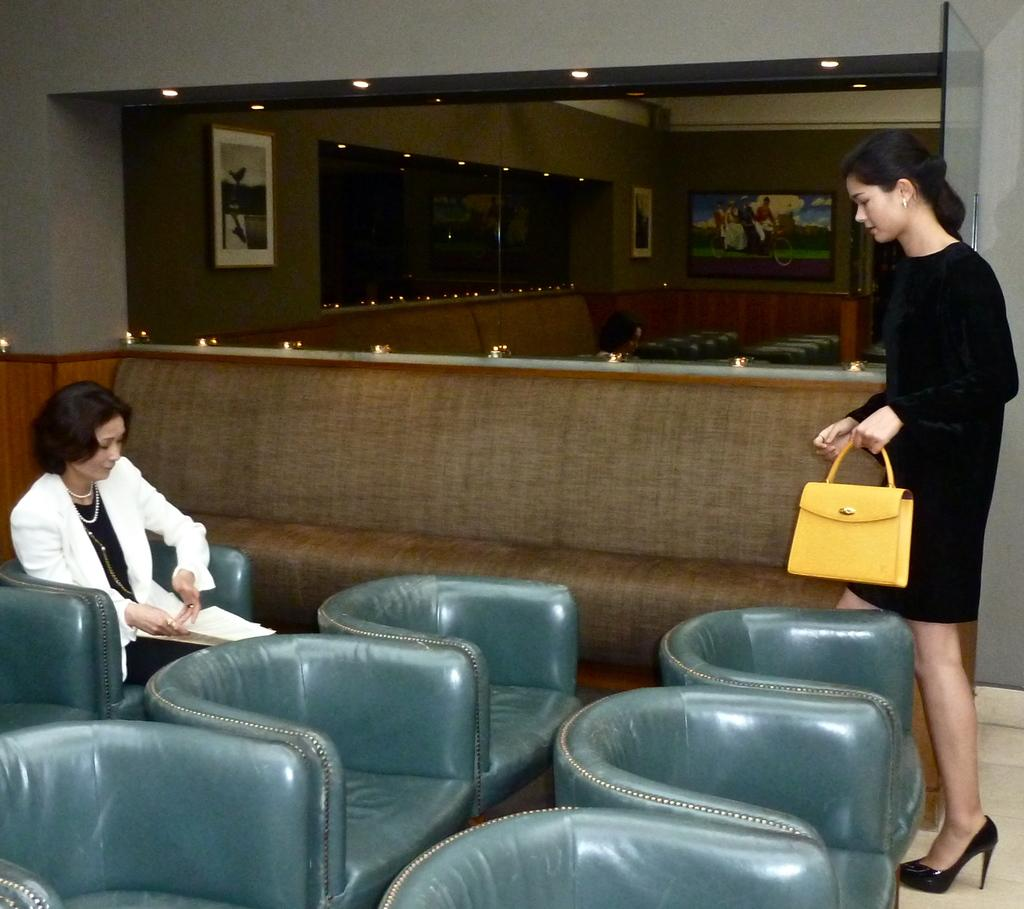What is the position of the woman in the image? There is a woman seated on a chair in the image, and another woman standing. What is the standing woman holding? The standing woman is holding a handbag. What type of slip can be seen on the side of the building in the image? There is no building or slip present in the image; it features two women, one seated and the other standing. 